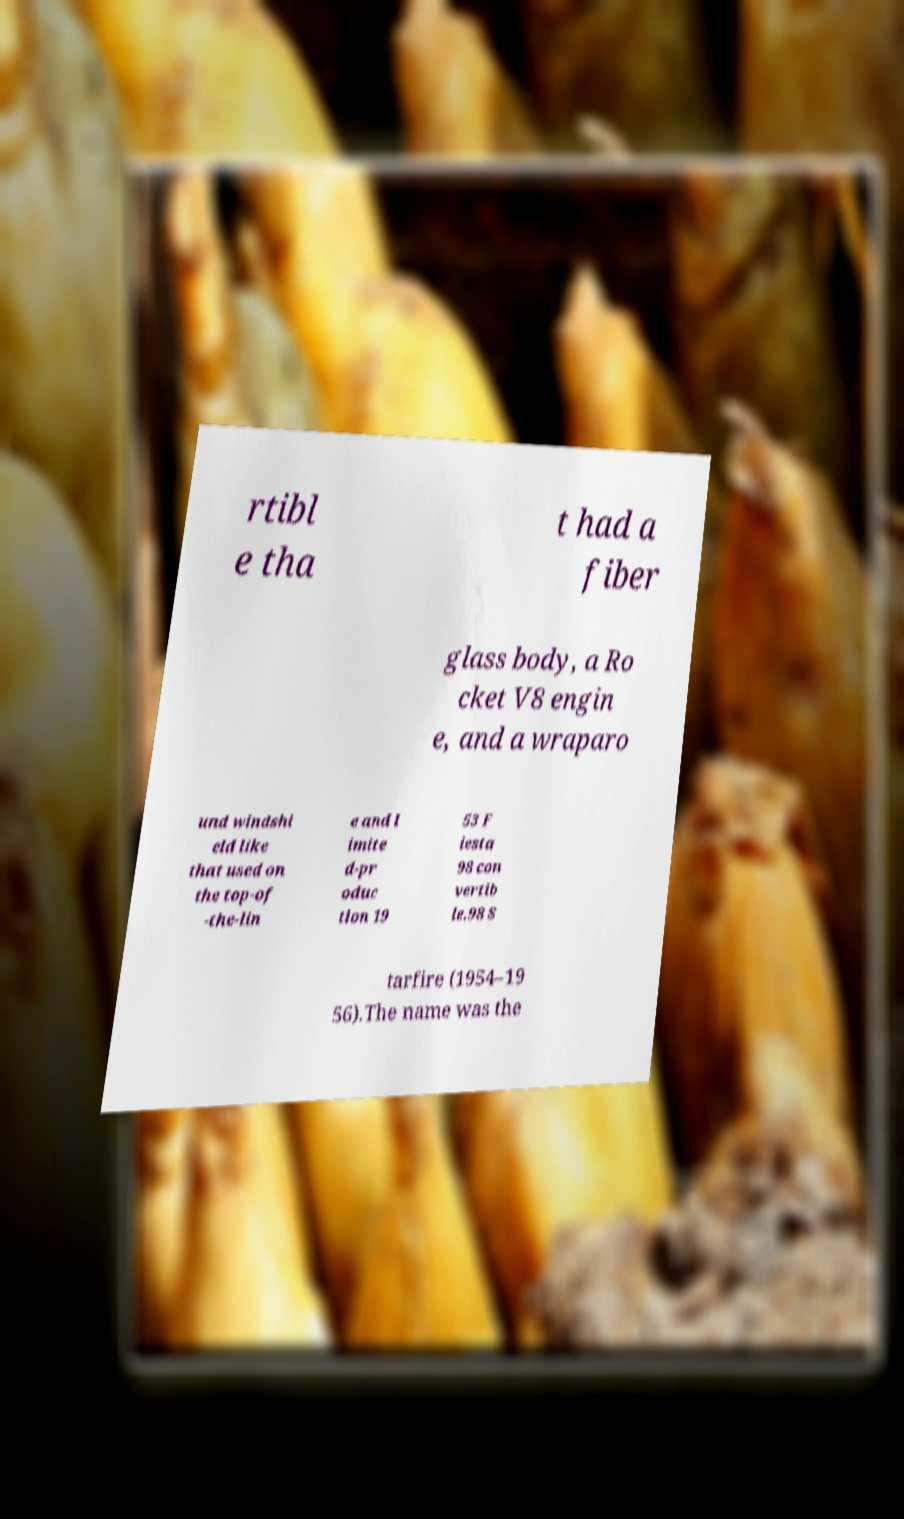Could you assist in decoding the text presented in this image and type it out clearly? rtibl e tha t had a fiber glass body, a Ro cket V8 engin e, and a wraparo und windshi eld like that used on the top-of -the-lin e and l imite d-pr oduc tion 19 53 F iesta 98 con vertib le.98 S tarfire (1954–19 56).The name was the 